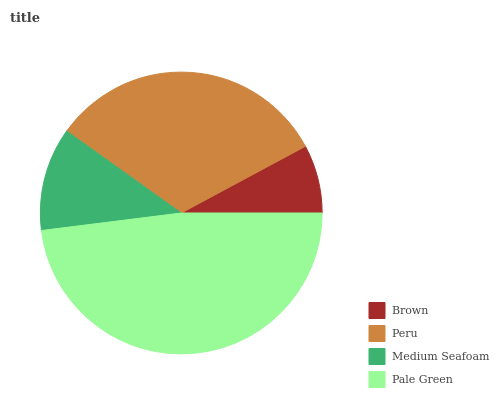Is Brown the minimum?
Answer yes or no. Yes. Is Pale Green the maximum?
Answer yes or no. Yes. Is Peru the minimum?
Answer yes or no. No. Is Peru the maximum?
Answer yes or no. No. Is Peru greater than Brown?
Answer yes or no. Yes. Is Brown less than Peru?
Answer yes or no. Yes. Is Brown greater than Peru?
Answer yes or no. No. Is Peru less than Brown?
Answer yes or no. No. Is Peru the high median?
Answer yes or no. Yes. Is Medium Seafoam the low median?
Answer yes or no. Yes. Is Pale Green the high median?
Answer yes or no. No. Is Brown the low median?
Answer yes or no. No. 